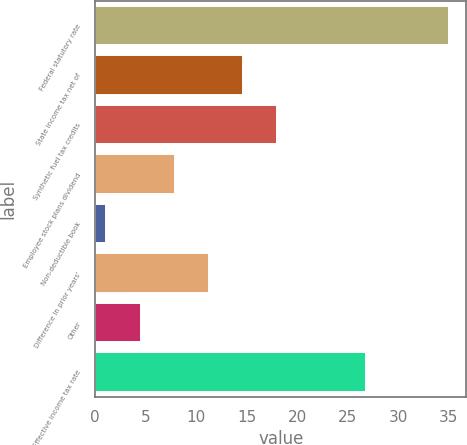<chart> <loc_0><loc_0><loc_500><loc_500><bar_chart><fcel>Federal statutory rate<fcel>State income tax net of<fcel>Synthetic fuel tax credits<fcel>Employee stock plans dividend<fcel>Non-deductible book<fcel>Difference in prior years'<fcel>Other<fcel>Effective income tax rate<nl><fcel>35<fcel>14.66<fcel>18.05<fcel>7.88<fcel>1.1<fcel>11.27<fcel>4.49<fcel>26.8<nl></chart> 